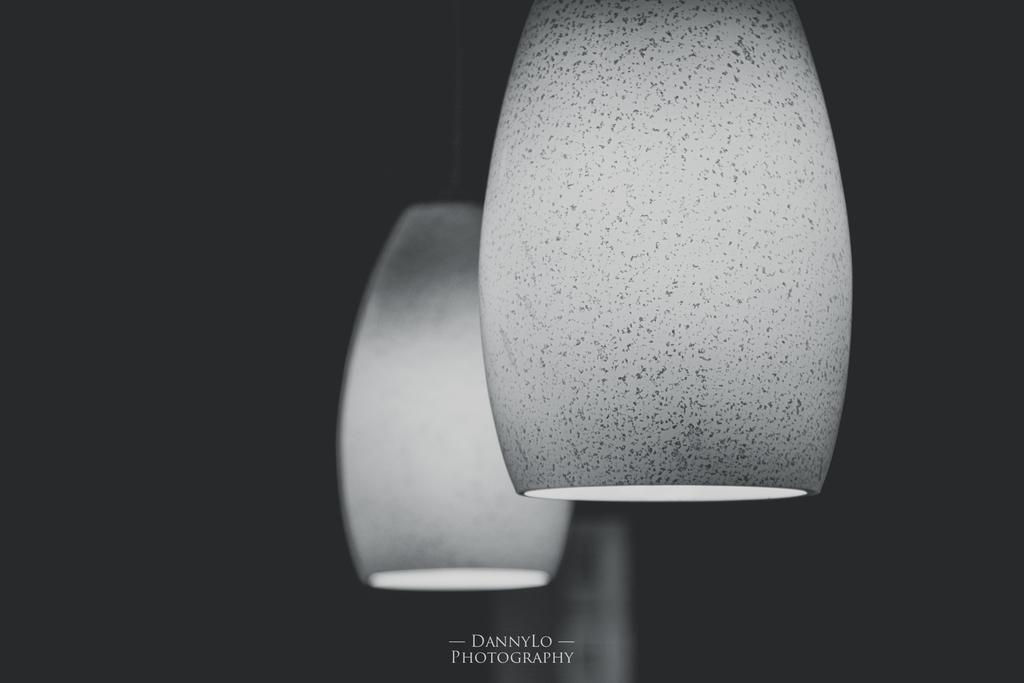What can be seen in the middle of the picture? There are decorative objects in the middle of the picture that resemble lights. How would you describe the lighting in the area around the decorative objects? The area around the decorative objects is dark. Is there any text present in the image? Yes, there is text at the bottom of the image. What type of plastic material is used to make the truck in the image? There is no truck present in the image, so it is not possible to determine the type of plastic material used. 